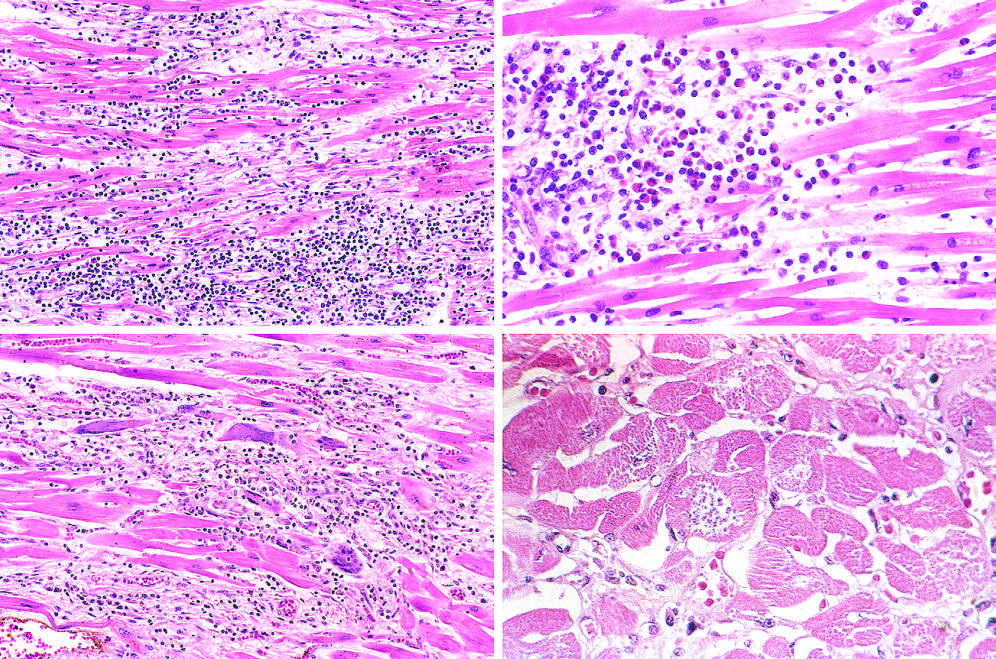s a myofiber distended with trypanosomes present, along with mononuclear inflammation and myofiber necrosis?
Answer the question using a single word or phrase. Yes 